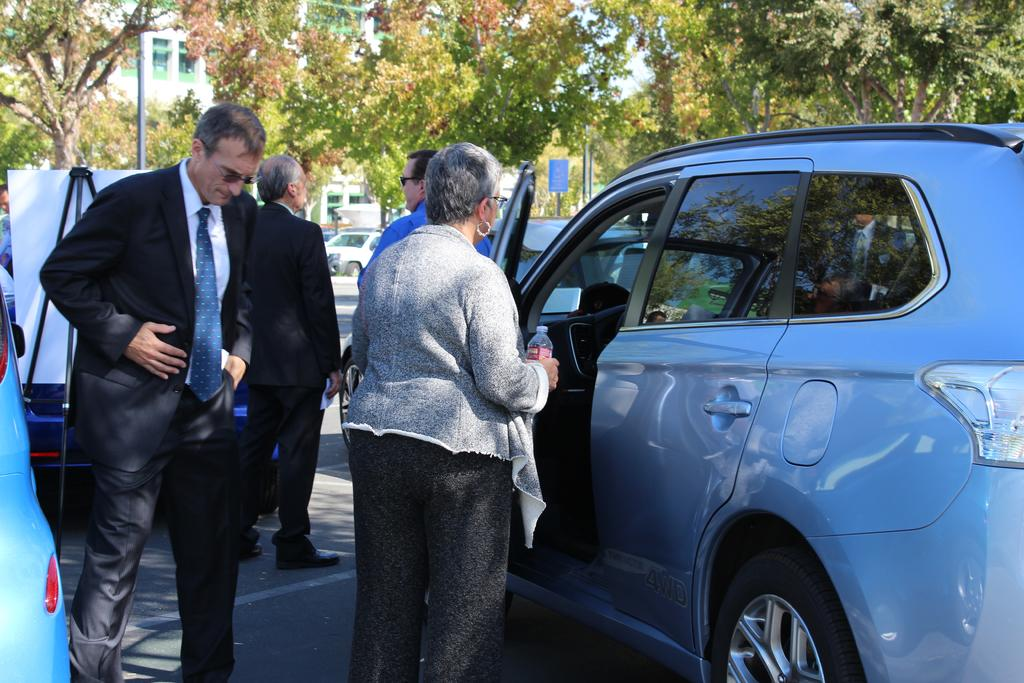What are the people in the image doing? The people in the image are standing on the road. What else can be seen in the image besides the people? There are vehicles, a board, trees, and a building visible in the image. Can you describe the board in the image? Unfortunately, the facts provided do not give enough information to describe the board in detail. What is visible in the background of the image? In the background, there are trees and a building. What type of silk fabric is draped over the gate in the image? There is no gate or silk fabric present in the image. What flavor of cake can be seen in the image? There is no cake present in the image. 